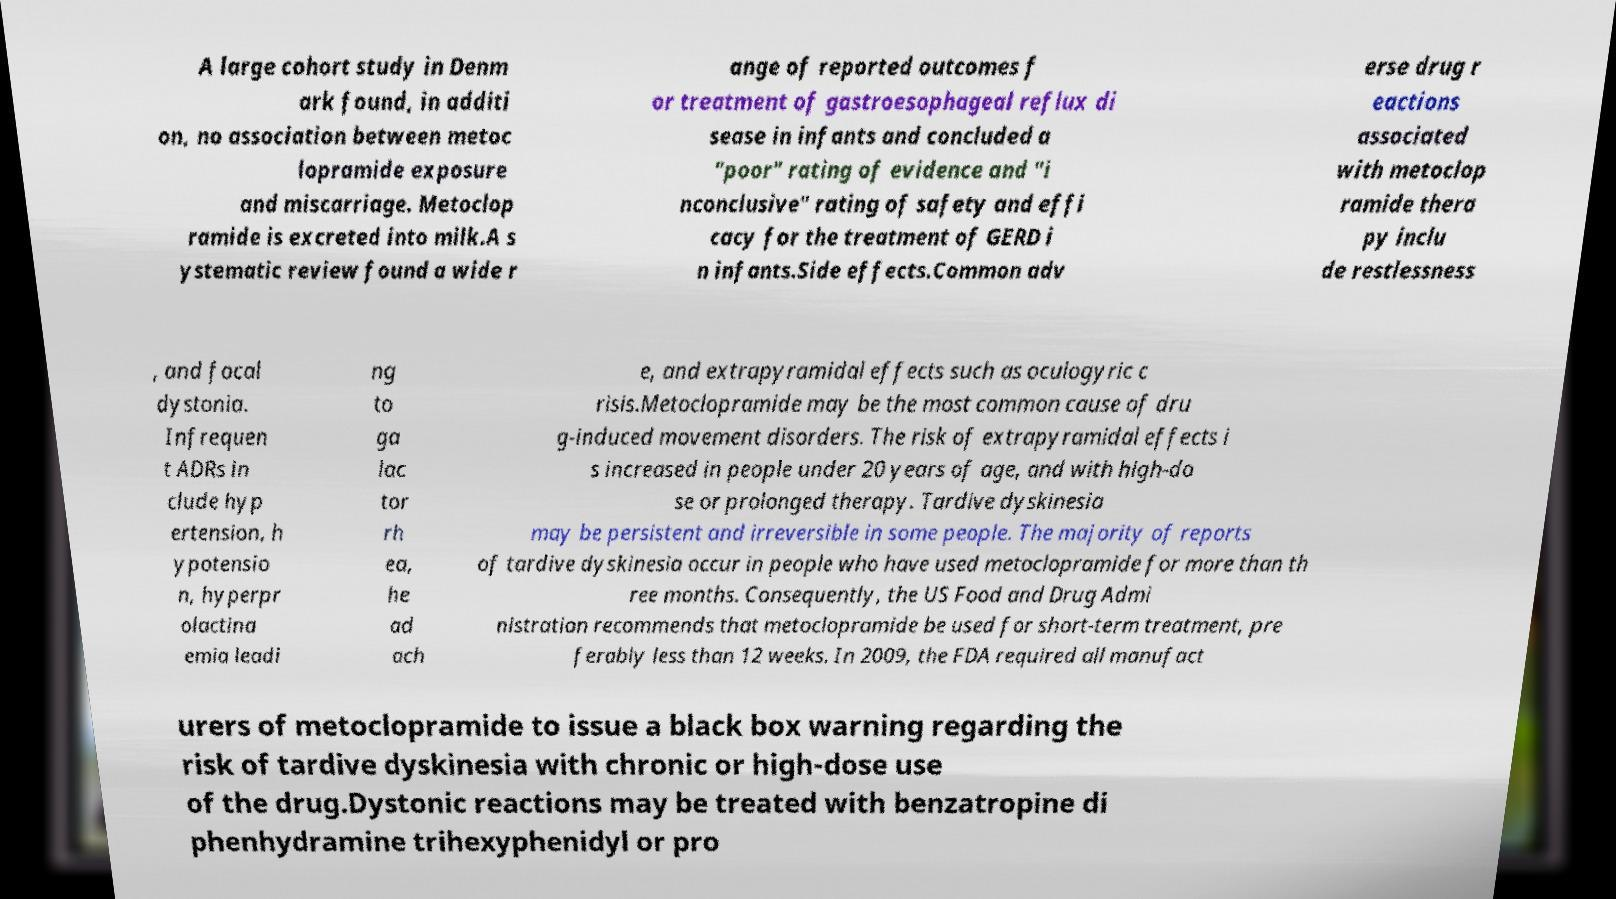Can you read and provide the text displayed in the image?This photo seems to have some interesting text. Can you extract and type it out for me? A large cohort study in Denm ark found, in additi on, no association between metoc lopramide exposure and miscarriage. Metoclop ramide is excreted into milk.A s ystematic review found a wide r ange of reported outcomes f or treatment of gastroesophageal reflux di sease in infants and concluded a "poor" rating of evidence and "i nconclusive" rating of safety and effi cacy for the treatment of GERD i n infants.Side effects.Common adv erse drug r eactions associated with metoclop ramide thera py inclu de restlessness , and focal dystonia. Infrequen t ADRs in clude hyp ertension, h ypotensio n, hyperpr olactina emia leadi ng to ga lac tor rh ea, he ad ach e, and extrapyramidal effects such as oculogyric c risis.Metoclopramide may be the most common cause of dru g-induced movement disorders. The risk of extrapyramidal effects i s increased in people under 20 years of age, and with high-do se or prolonged therapy. Tardive dyskinesia may be persistent and irreversible in some people. The majority of reports of tardive dyskinesia occur in people who have used metoclopramide for more than th ree months. Consequently, the US Food and Drug Admi nistration recommends that metoclopramide be used for short-term treatment, pre ferably less than 12 weeks. In 2009, the FDA required all manufact urers of metoclopramide to issue a black box warning regarding the risk of tardive dyskinesia with chronic or high-dose use of the drug.Dystonic reactions may be treated with benzatropine di phenhydramine trihexyphenidyl or pro 